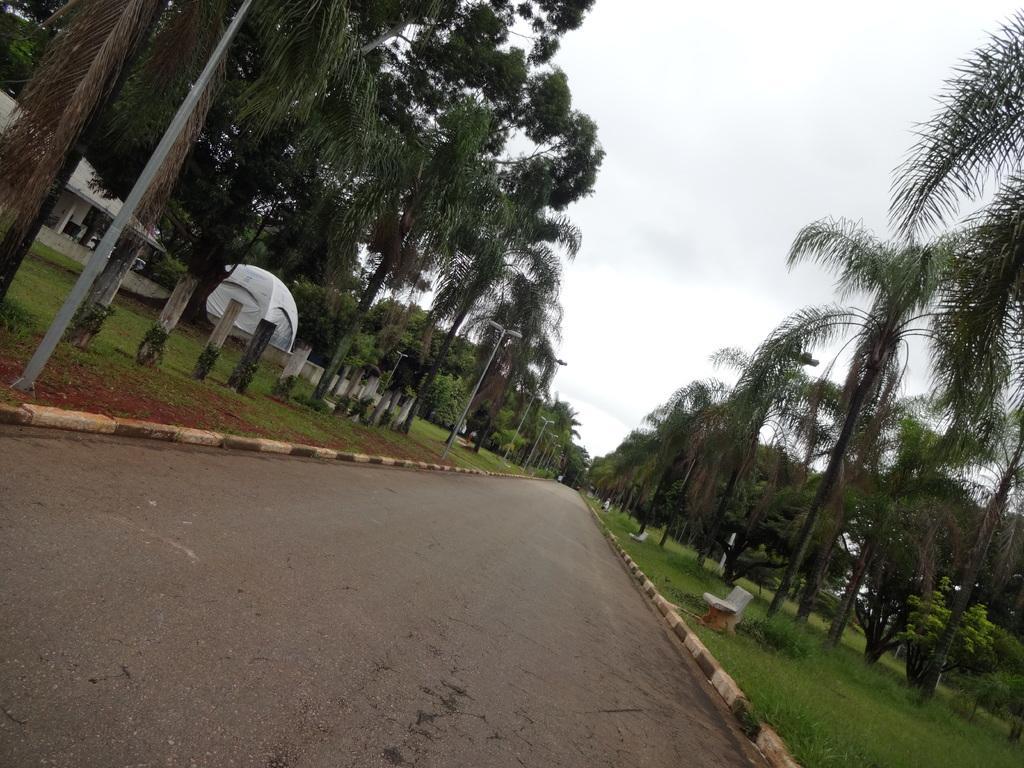Describe this image in one or two sentences. In this picture we can see road, bench, light poles, wooden poles, trees, grass, pillars and tent. In the background of the image we can see the sky. 